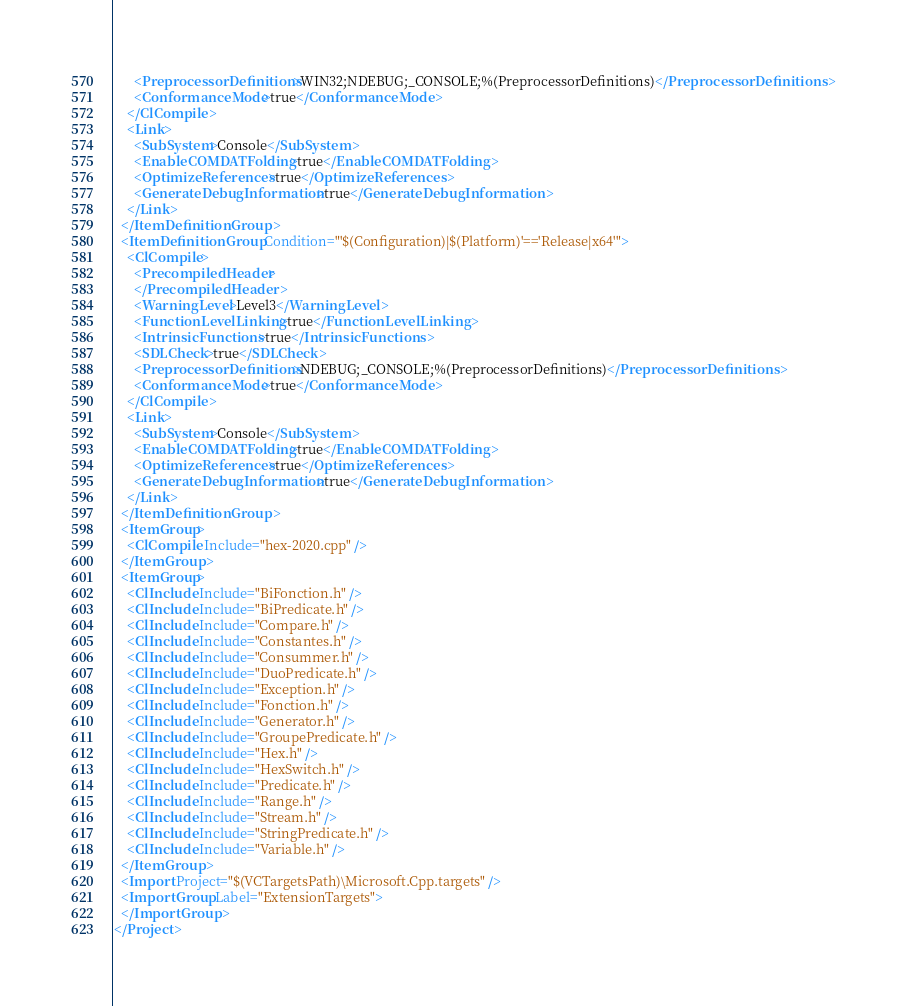Convert code to text. <code><loc_0><loc_0><loc_500><loc_500><_XML_>      <PreprocessorDefinitions>WIN32;NDEBUG;_CONSOLE;%(PreprocessorDefinitions)</PreprocessorDefinitions>
      <ConformanceMode>true</ConformanceMode>
    </ClCompile>
    <Link>
      <SubSystem>Console</SubSystem>
      <EnableCOMDATFolding>true</EnableCOMDATFolding>
      <OptimizeReferences>true</OptimizeReferences>
      <GenerateDebugInformation>true</GenerateDebugInformation>
    </Link>
  </ItemDefinitionGroup>
  <ItemDefinitionGroup Condition="'$(Configuration)|$(Platform)'=='Release|x64'">
    <ClCompile>
      <PrecompiledHeader>
      </PrecompiledHeader>
      <WarningLevel>Level3</WarningLevel>
      <FunctionLevelLinking>true</FunctionLevelLinking>
      <IntrinsicFunctions>true</IntrinsicFunctions>
      <SDLCheck>true</SDLCheck>
      <PreprocessorDefinitions>NDEBUG;_CONSOLE;%(PreprocessorDefinitions)</PreprocessorDefinitions>
      <ConformanceMode>true</ConformanceMode>
    </ClCompile>
    <Link>
      <SubSystem>Console</SubSystem>
      <EnableCOMDATFolding>true</EnableCOMDATFolding>
      <OptimizeReferences>true</OptimizeReferences>
      <GenerateDebugInformation>true</GenerateDebugInformation>
    </Link>
  </ItemDefinitionGroup>
  <ItemGroup>
    <ClCompile Include="hex-2020.cpp" />
  </ItemGroup>
  <ItemGroup>
    <ClInclude Include="BiFonction.h" />
    <ClInclude Include="BiPredicate.h" />
    <ClInclude Include="Compare.h" />
    <ClInclude Include="Constantes.h" />
    <ClInclude Include="Consummer.h" />
    <ClInclude Include="DuoPredicate.h" />
    <ClInclude Include="Exception.h" />
    <ClInclude Include="Fonction.h" />
    <ClInclude Include="Generator.h" />
    <ClInclude Include="GroupePredicate.h" />
    <ClInclude Include="Hex.h" />
    <ClInclude Include="HexSwitch.h" />
    <ClInclude Include="Predicate.h" />
    <ClInclude Include="Range.h" />
    <ClInclude Include="Stream.h" />
    <ClInclude Include="StringPredicate.h" />
    <ClInclude Include="Variable.h" />
  </ItemGroup>
  <Import Project="$(VCTargetsPath)\Microsoft.Cpp.targets" />
  <ImportGroup Label="ExtensionTargets">
  </ImportGroup>
</Project></code> 